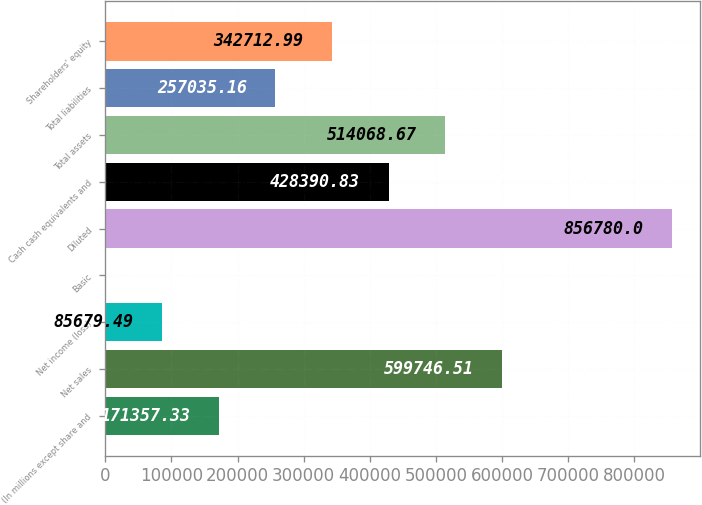Convert chart. <chart><loc_0><loc_0><loc_500><loc_500><bar_chart><fcel>(In millions except share and<fcel>Net sales<fcel>Net income (loss)<fcel>Basic<fcel>Diluted<fcel>Cash cash equivalents and<fcel>Total assets<fcel>Total liabilities<fcel>Shareholders' equity<nl><fcel>171357<fcel>599747<fcel>85679.5<fcel>1.65<fcel>856780<fcel>428391<fcel>514069<fcel>257035<fcel>342713<nl></chart> 